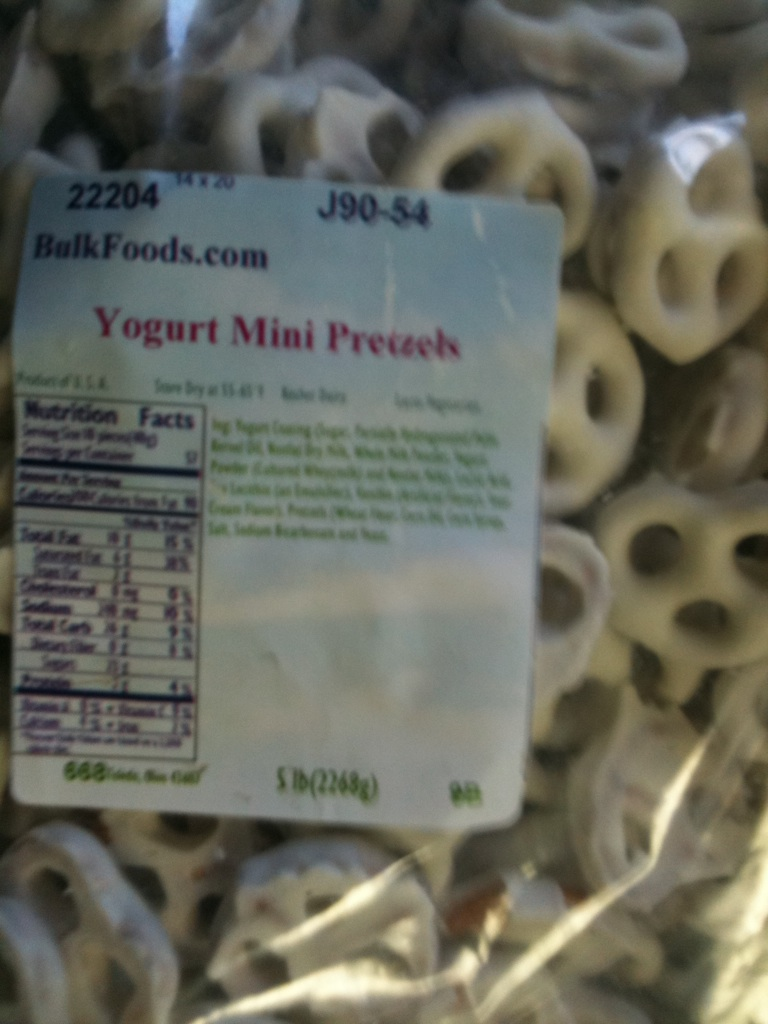Describe an imaginative scenario where these pretzels play a central role. Imagine this: In a magical world where snacks come to life, these Yogurt Mini Pretzels are the main characters in a heroic tale. They embark on a journey to rescue the Sweetlands from the evil Salty Snacks King. With their crunchy bravery and sweet wisdom, they navigate through treacherous lands of sour gummy swamps and caramel mountains. In the end, they unite the sweet and salty snacks, bringing harmony and deliciousness to the lands forever! 